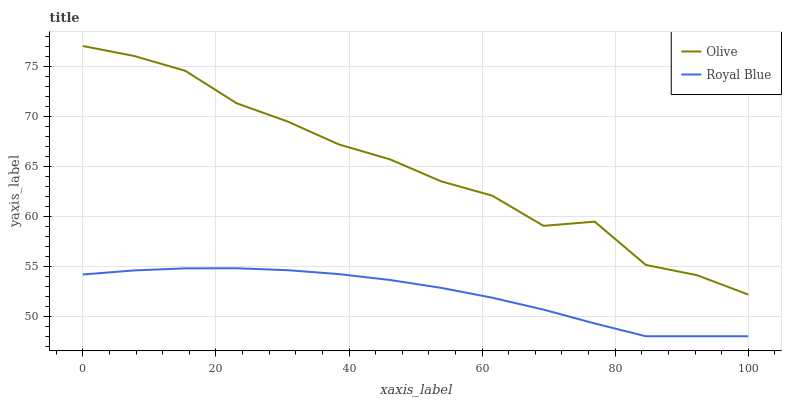Does Royal Blue have the minimum area under the curve?
Answer yes or no. Yes. Does Olive have the maximum area under the curve?
Answer yes or no. Yes. Does Royal Blue have the maximum area under the curve?
Answer yes or no. No. Is Royal Blue the smoothest?
Answer yes or no. Yes. Is Olive the roughest?
Answer yes or no. Yes. Is Royal Blue the roughest?
Answer yes or no. No. Does Olive have the highest value?
Answer yes or no. Yes. Does Royal Blue have the highest value?
Answer yes or no. No. Is Royal Blue less than Olive?
Answer yes or no. Yes. Is Olive greater than Royal Blue?
Answer yes or no. Yes. Does Royal Blue intersect Olive?
Answer yes or no. No. 